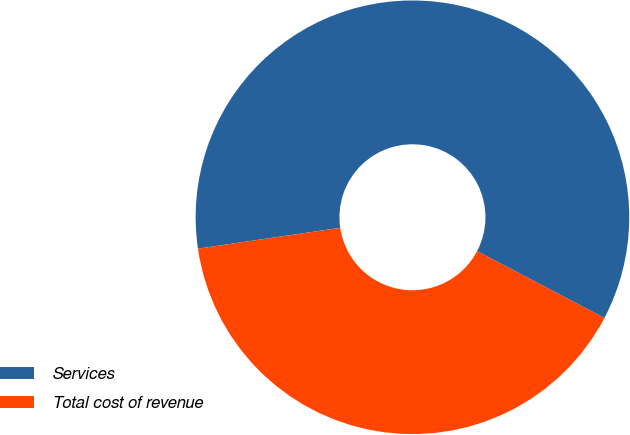Convert chart to OTSL. <chart><loc_0><loc_0><loc_500><loc_500><pie_chart><fcel>Services<fcel>Total cost of revenue<nl><fcel>60.0%<fcel>40.0%<nl></chart> 